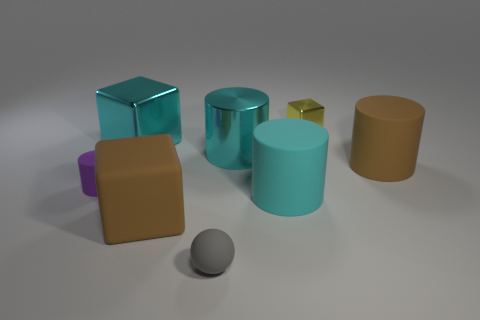There is a yellow block; is it the same size as the brown object in front of the purple object?
Your answer should be very brief. No. There is a big cube that is the same color as the large metallic cylinder; what material is it?
Your answer should be very brief. Metal. What is the size of the cylinder that is to the right of the cylinder in front of the cylinder that is on the left side of the large cyan metal cylinder?
Your response must be concise. Large. Are there more big rubber cylinders that are behind the tiny purple rubber cylinder than rubber balls that are to the left of the gray matte object?
Your response must be concise. Yes. How many cyan objects are to the left of the small thing that is behind the big metallic cylinder?
Offer a very short reply. 3. Is there a rubber object that has the same color as the big metal block?
Your answer should be compact. Yes. Do the rubber sphere and the yellow shiny block have the same size?
Make the answer very short. Yes. Does the big metal cylinder have the same color as the big shiny cube?
Ensure brevity in your answer.  Yes. There is a big cube right of the cyan thing to the left of the cyan shiny cylinder; what is its material?
Provide a short and direct response. Rubber. There is another cyan thing that is the same shape as the tiny metal object; what is its material?
Ensure brevity in your answer.  Metal. 